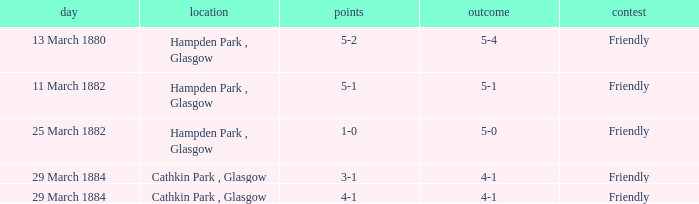Which item has a score of 5-1? 5-1. 